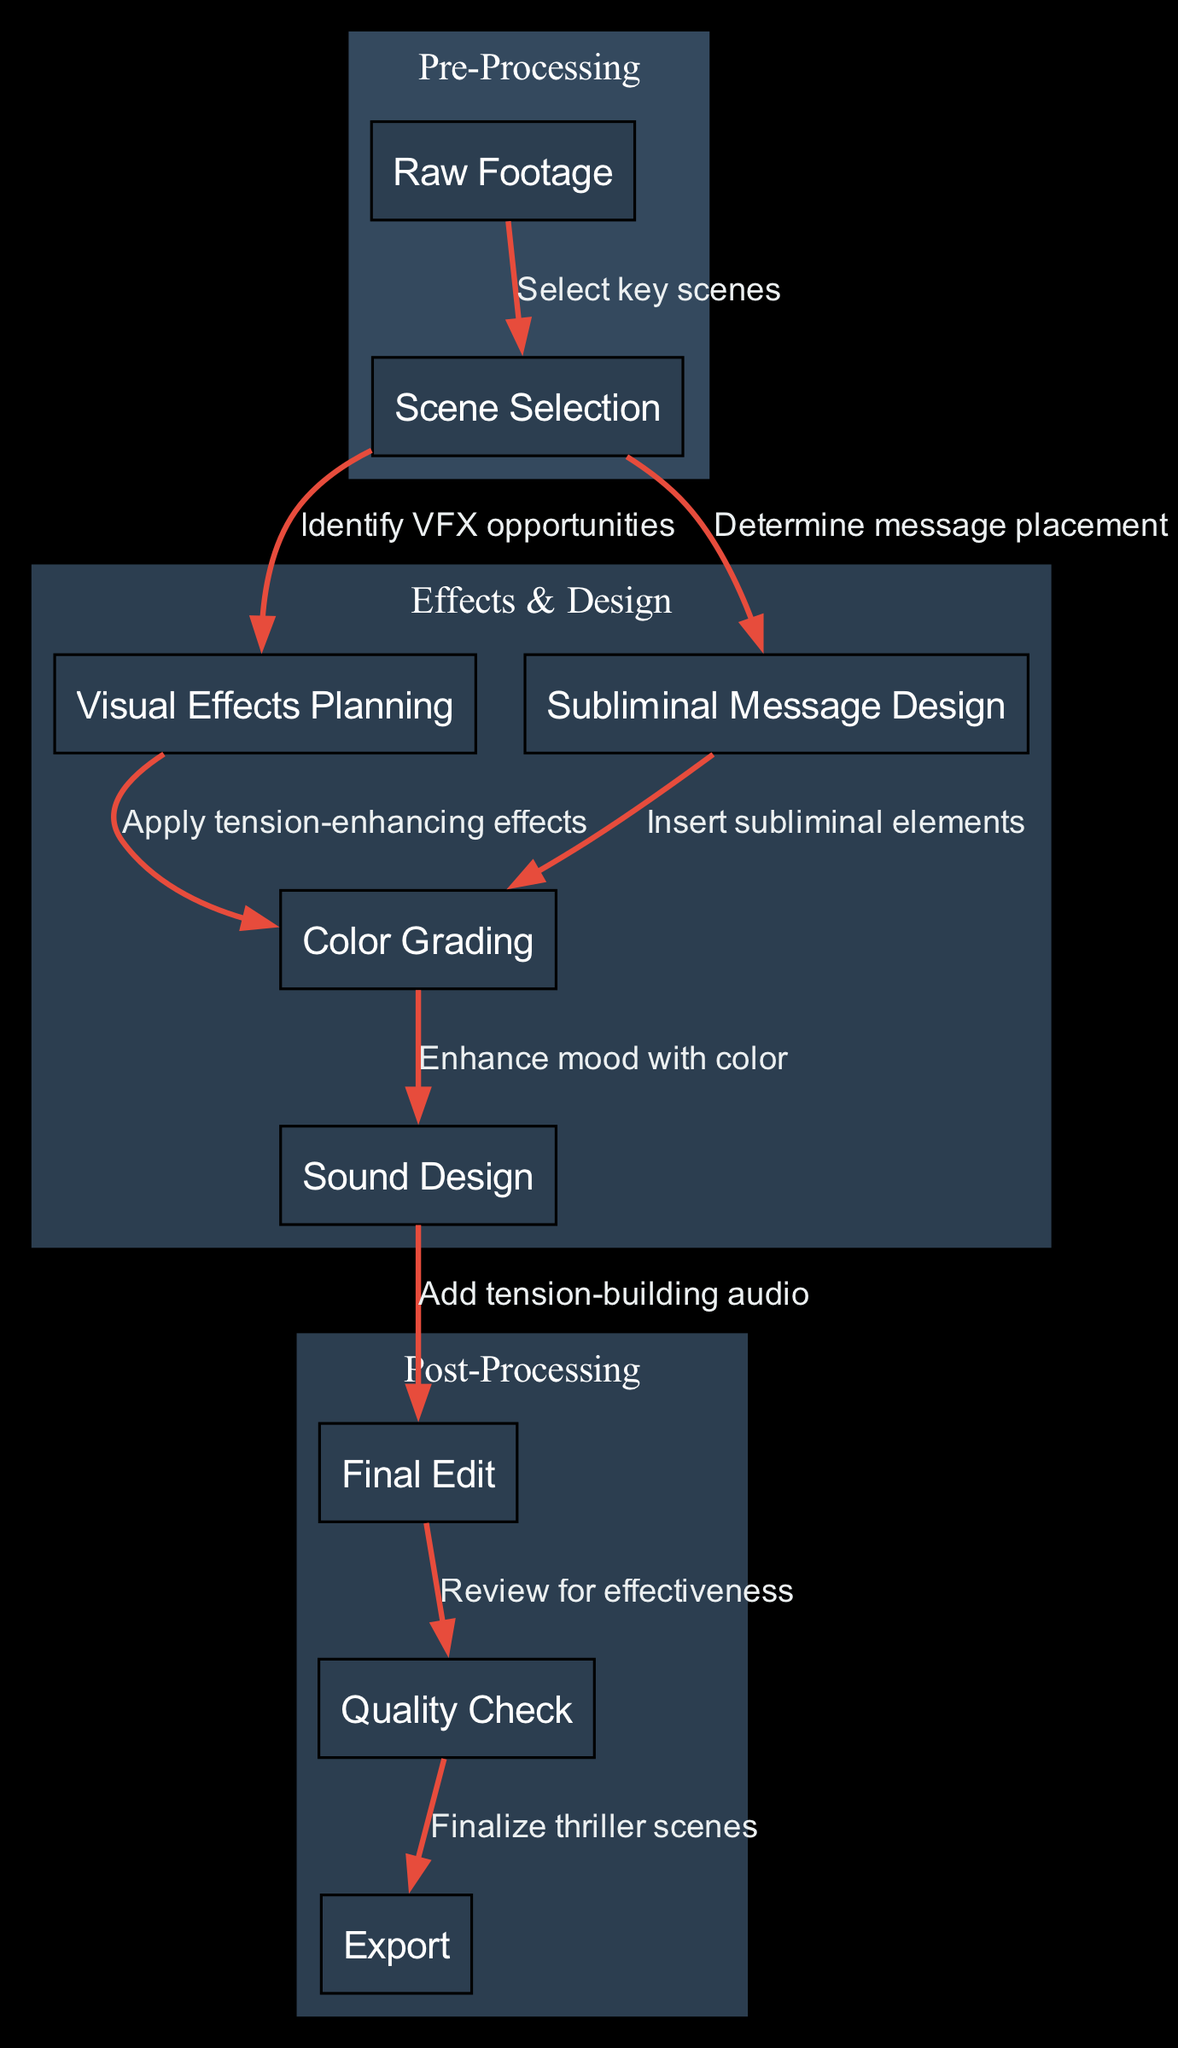What is the first step in the workflow? The first node in the workflow is "Raw Footage," which is indicated at the start of the diagram. This is where the entire process begins.
Answer: Raw Footage How many total nodes are there in the diagram? By counting the nodes listed, there are a total of nine distinct nodes in the workflow diagram.
Answer: 9 What is the relationship between "Scene Selection" and "Visual Effects Planning"? The diagram shows an edge from "Scene Selection" to "Visual Effects Planning," labeled as "Identify VFX opportunities," indicating that after selecting scenes, the next step is to plan visual effects.
Answer: Identify VFX opportunities Which node follows "Sound Design"? Following "Sound Design," the next node in the workflow is "Final Edit," showing the progression from sound design to final editing of the scenes.
Answer: Final Edit What is the last step of the workflow? The final node in the workflow as shown in the diagram is "Export," indicating this is the last action taken after all other processes are completed.
Answer: Export How many edges connect to "Color Grading"? "Color Grading" is connected to two edges: one from "Visual Effects Planning" and the other from "Sound Design," indicating it is a part of both the effects design and sound design phases.
Answer: 2 What step comes after "Subliminal Message Design"? The diagram indicates that after "Subliminal Message Design," the next step is "Color Grading," which is where subliminal elements are further integrated into the scene visual aspects.
Answer: Color Grading Which two processes are connected to "Color Grading"? The processes connected to "Color Grading" are "Visual Effects Planning" and "Sound Design," showing that it is influenced by both the visual and audio designs in enhancing the scenes.
Answer: Visual Effects Planning and Sound Design How are subliminal messages integrated according to the workflow? Subliminal messages are inserted during the "Subliminal Message Design" step, which then flows into "Color Grading," indicating the final integration into the visual presentation of the scenes.
Answer: Insert subliminal elements 